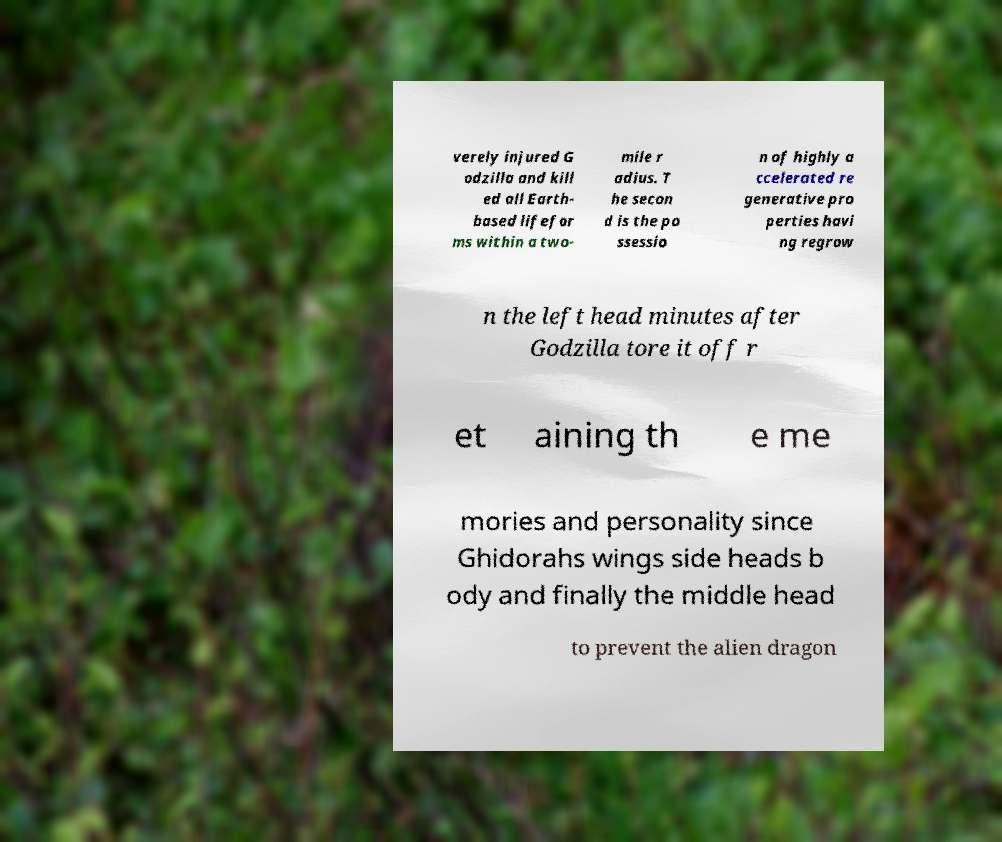Can you accurately transcribe the text from the provided image for me? verely injured G odzilla and kill ed all Earth- based lifefor ms within a two- mile r adius. T he secon d is the po ssessio n of highly a ccelerated re generative pro perties havi ng regrow n the left head minutes after Godzilla tore it off r et aining th e me mories and personality since Ghidorahs wings side heads b ody and finally the middle head to prevent the alien dragon 